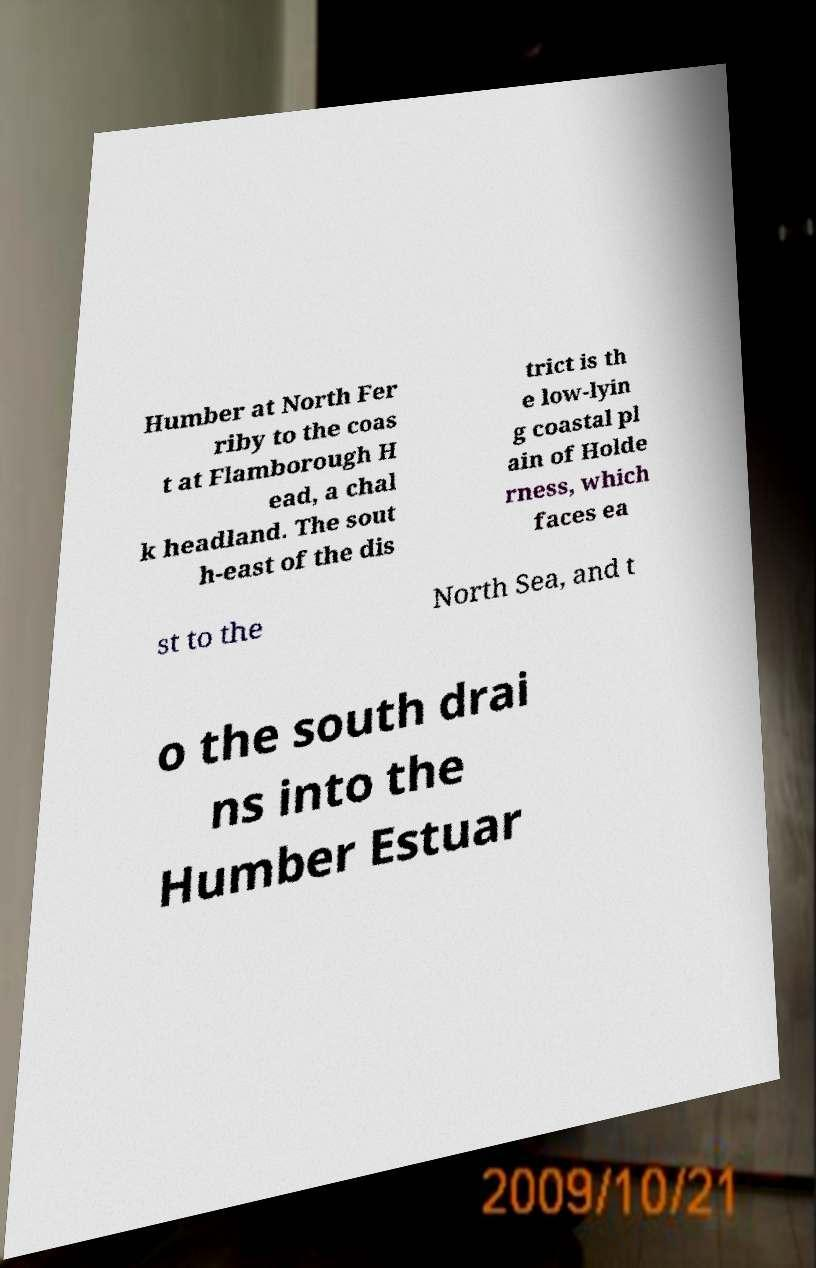Please read and relay the text visible in this image. What does it say? Humber at North Fer riby to the coas t at Flamborough H ead, a chal k headland. The sout h-east of the dis trict is th e low-lyin g coastal pl ain of Holde rness, which faces ea st to the North Sea, and t o the south drai ns into the Humber Estuar 